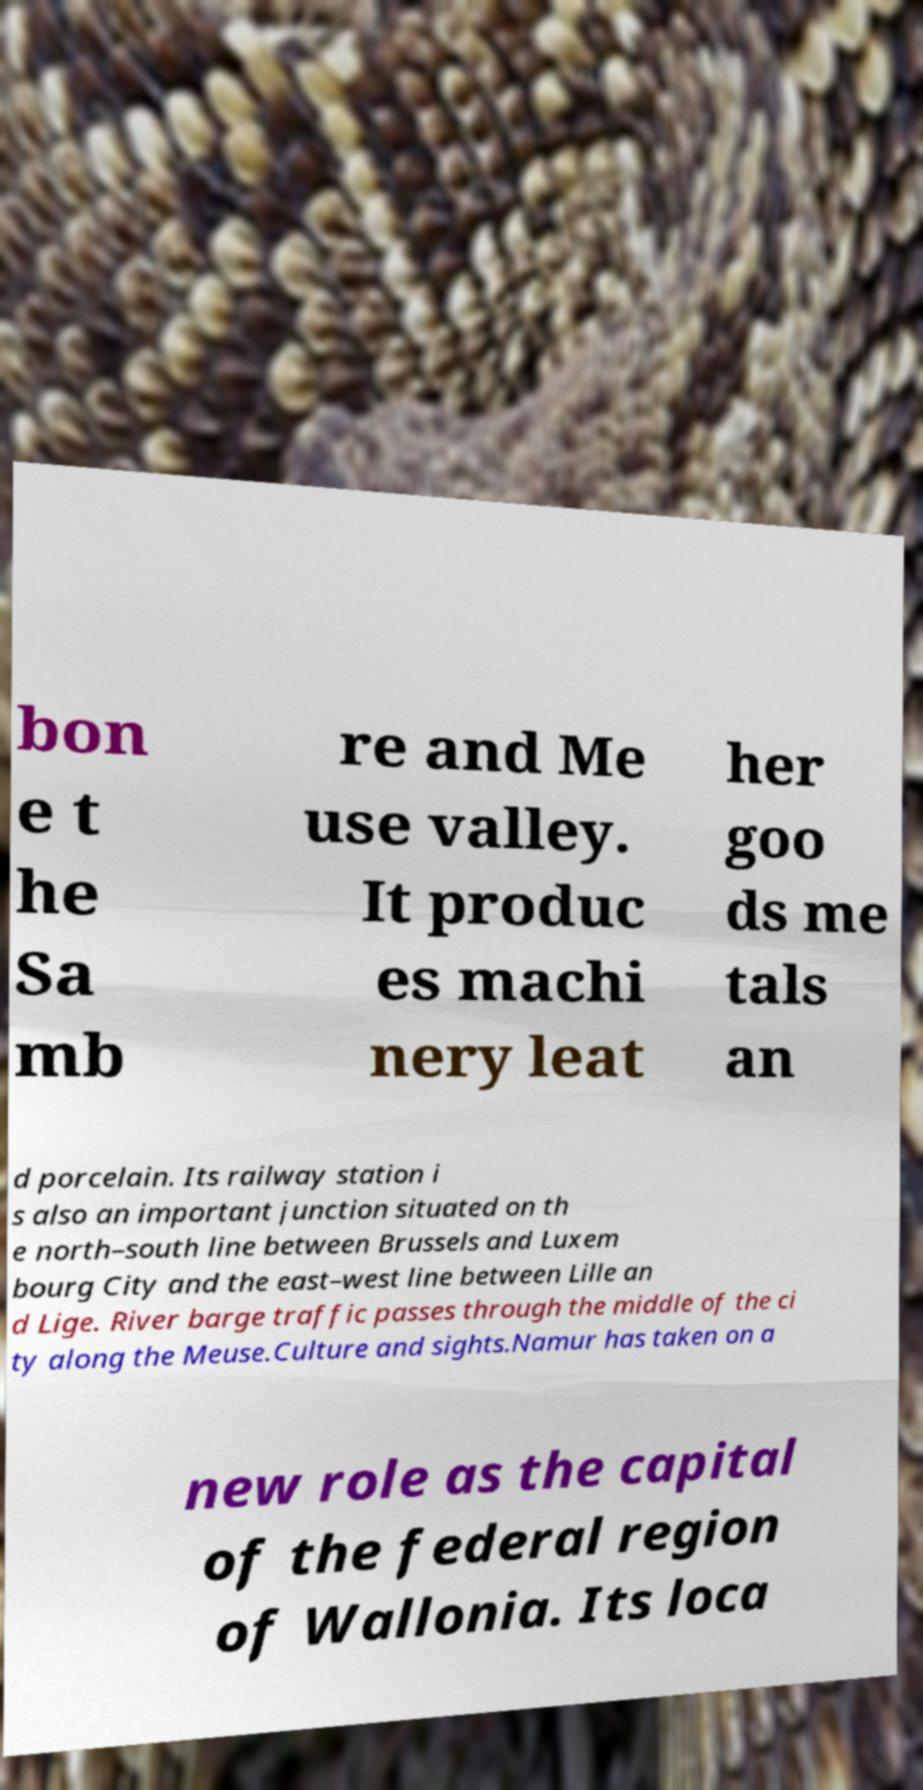Please read and relay the text visible in this image. What does it say? bon e t he Sa mb re and Me use valley. It produc es machi nery leat her goo ds me tals an d porcelain. Its railway station i s also an important junction situated on th e north–south line between Brussels and Luxem bourg City and the east–west line between Lille an d Lige. River barge traffic passes through the middle of the ci ty along the Meuse.Culture and sights.Namur has taken on a new role as the capital of the federal region of Wallonia. Its loca 